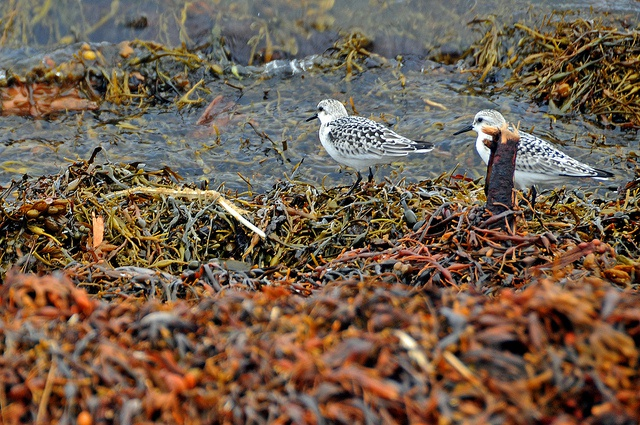Describe the objects in this image and their specific colors. I can see bird in gray, darkgray, lightgray, and black tones and bird in gray, lightgray, and darkgray tones in this image. 